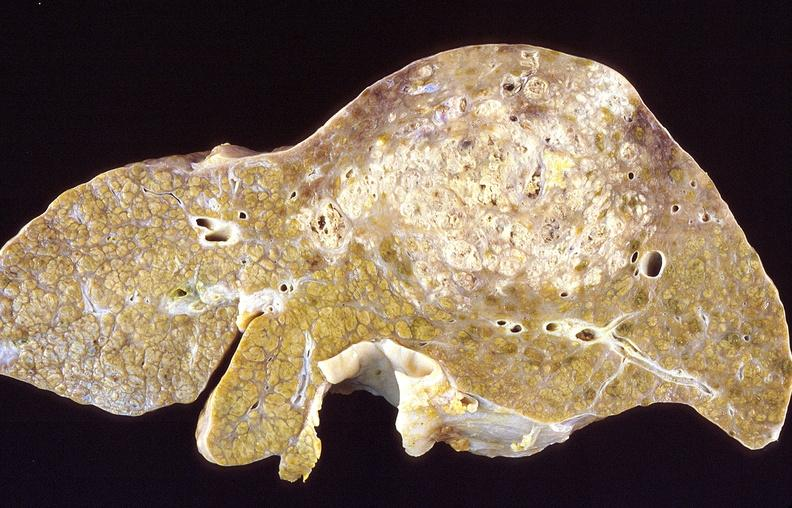what is present?
Answer the question using a single word or phrase. Hepatobiliary 